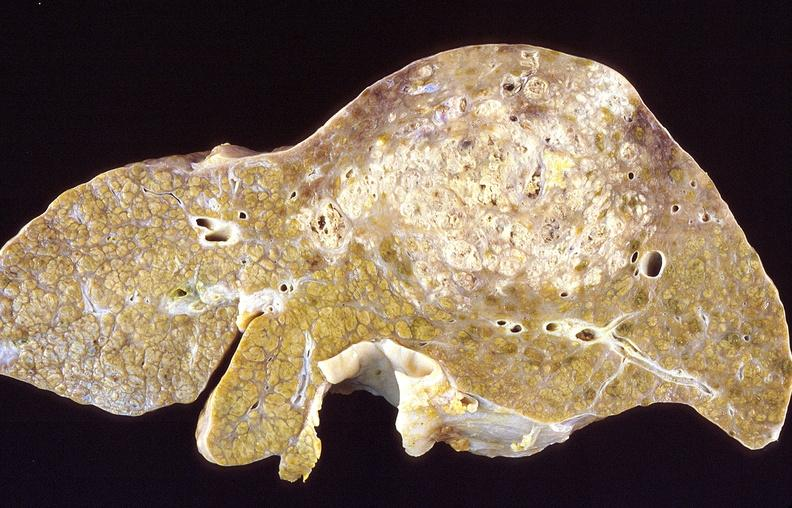what is present?
Answer the question using a single word or phrase. Hepatobiliary 